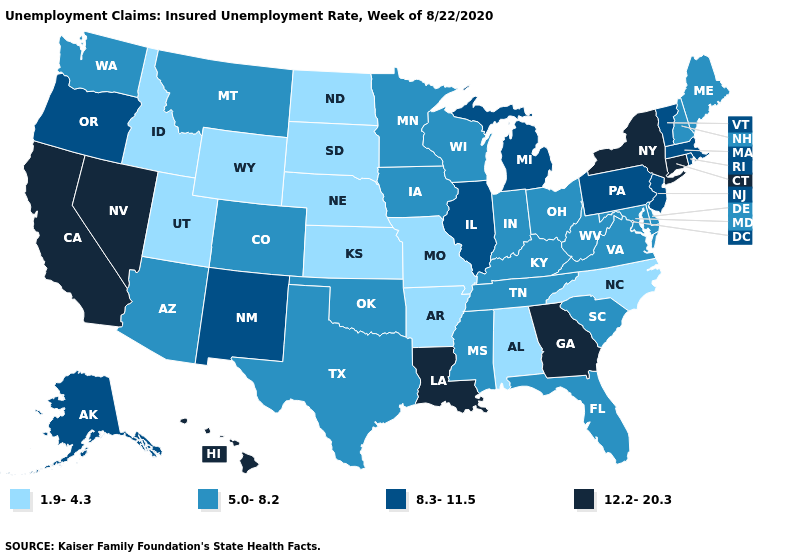What is the value of Massachusetts?
Answer briefly. 8.3-11.5. What is the value of Wyoming?
Write a very short answer. 1.9-4.3. Name the states that have a value in the range 1.9-4.3?
Write a very short answer. Alabama, Arkansas, Idaho, Kansas, Missouri, Nebraska, North Carolina, North Dakota, South Dakota, Utah, Wyoming. Among the states that border Wyoming , which have the lowest value?
Answer briefly. Idaho, Nebraska, South Dakota, Utah. Among the states that border Colorado , which have the lowest value?
Be succinct. Kansas, Nebraska, Utah, Wyoming. Among the states that border Washington , which have the highest value?
Quick response, please. Oregon. Among the states that border Wisconsin , which have the lowest value?
Concise answer only. Iowa, Minnesota. Does New Hampshire have a lower value than Nebraska?
Quick response, please. No. Name the states that have a value in the range 1.9-4.3?
Answer briefly. Alabama, Arkansas, Idaho, Kansas, Missouri, Nebraska, North Carolina, North Dakota, South Dakota, Utah, Wyoming. Name the states that have a value in the range 12.2-20.3?
Write a very short answer. California, Connecticut, Georgia, Hawaii, Louisiana, Nevada, New York. Name the states that have a value in the range 5.0-8.2?
Short answer required. Arizona, Colorado, Delaware, Florida, Indiana, Iowa, Kentucky, Maine, Maryland, Minnesota, Mississippi, Montana, New Hampshire, Ohio, Oklahoma, South Carolina, Tennessee, Texas, Virginia, Washington, West Virginia, Wisconsin. What is the value of Illinois?
Keep it brief. 8.3-11.5. Name the states that have a value in the range 5.0-8.2?
Answer briefly. Arizona, Colorado, Delaware, Florida, Indiana, Iowa, Kentucky, Maine, Maryland, Minnesota, Mississippi, Montana, New Hampshire, Ohio, Oklahoma, South Carolina, Tennessee, Texas, Virginia, Washington, West Virginia, Wisconsin. What is the value of Minnesota?
Write a very short answer. 5.0-8.2. What is the value of Rhode Island?
Concise answer only. 8.3-11.5. 